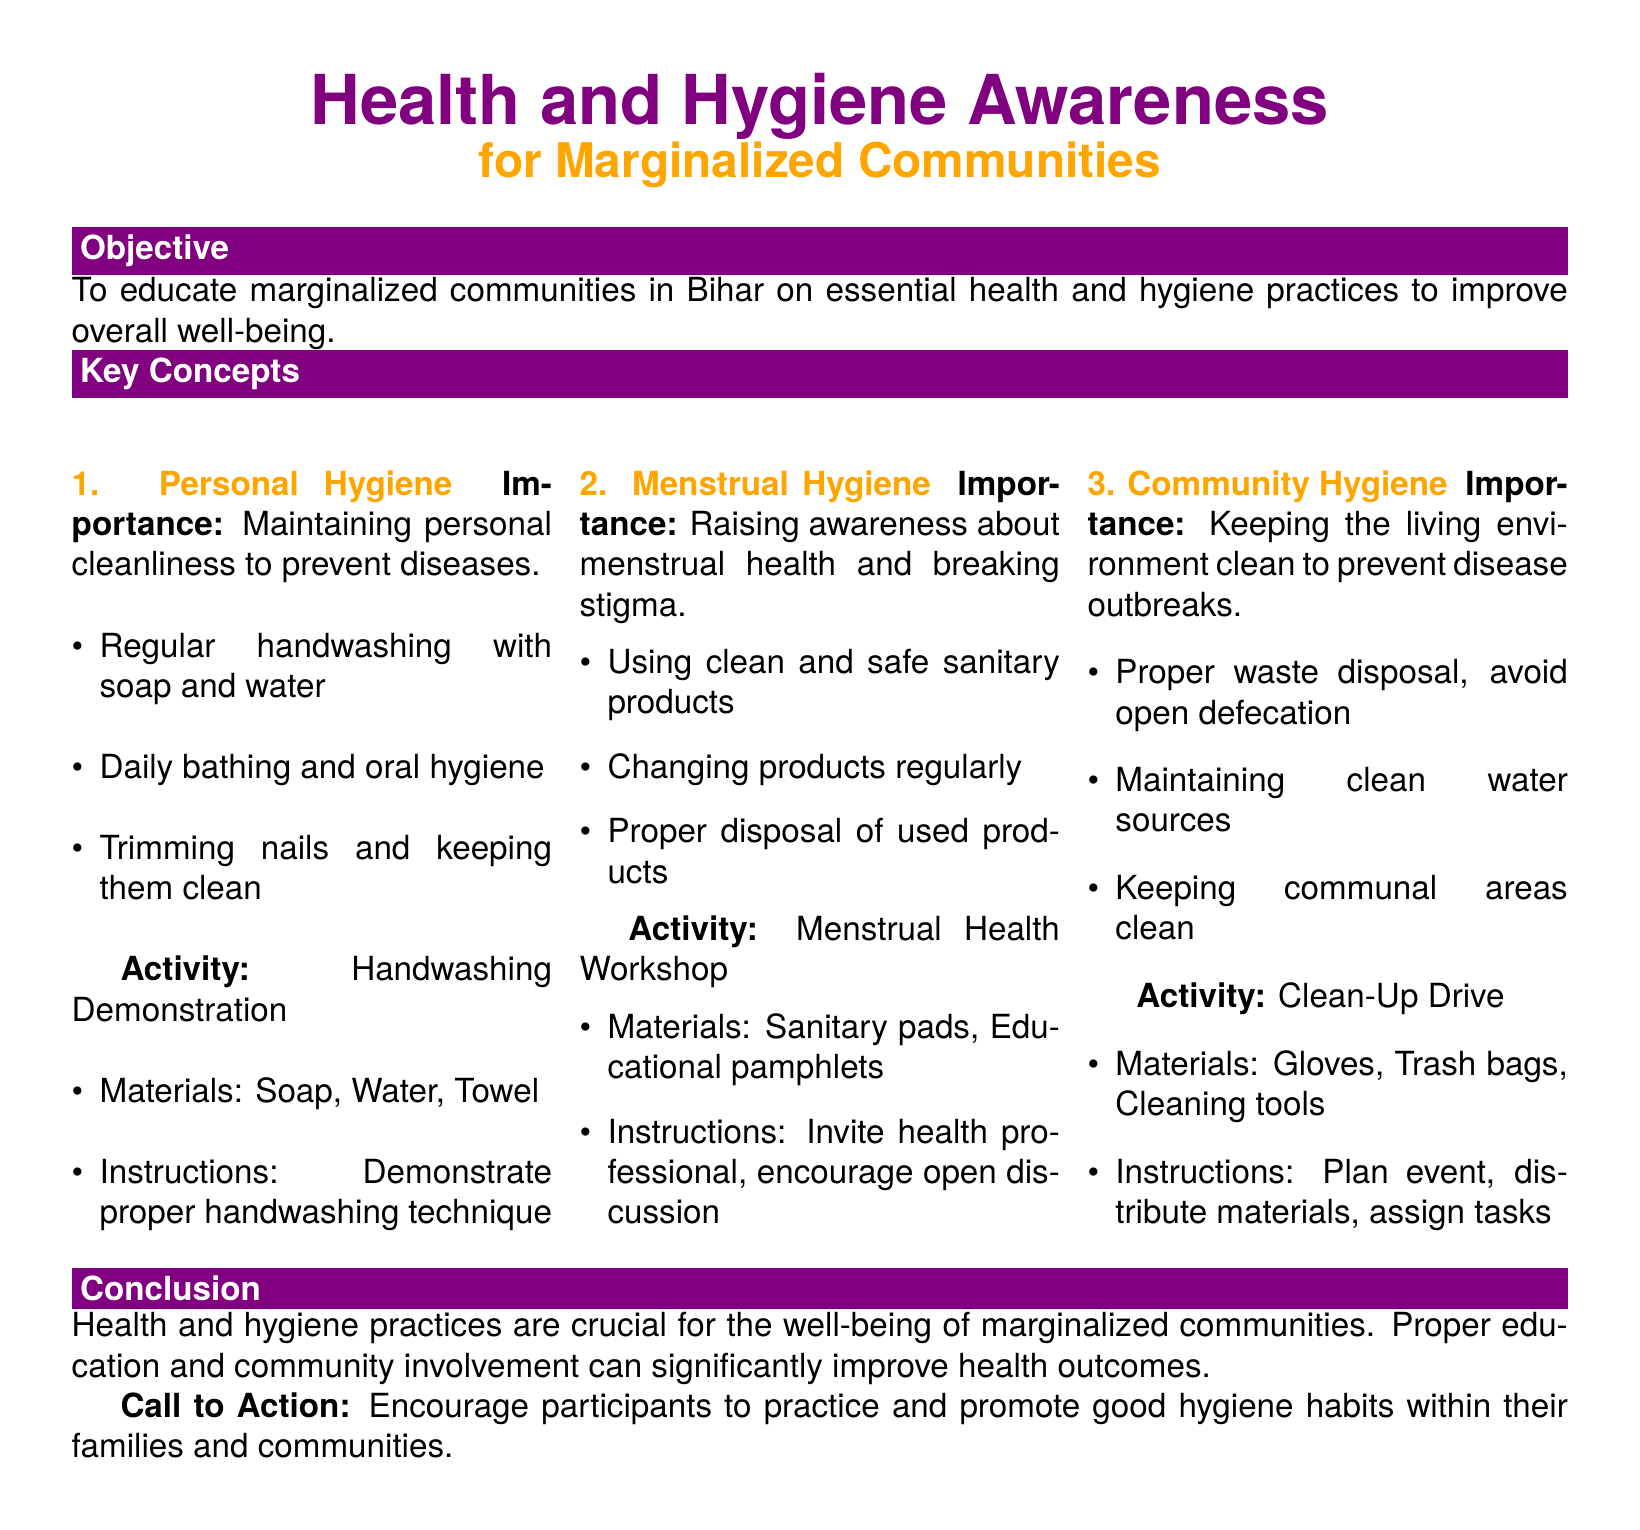What is the main objective of the lesson plan? The main objective is to educate marginalized communities in Bihar on essential health and hygiene practices to improve overall well-being.
Answer: To educate marginalized communities in Bihar on essential health and hygiene practices to improve overall well-being How many key concepts are discussed in the lesson plan? The document lists three key concepts related to health and hygiene awareness.
Answer: Three What is one activity related to personal hygiene? The activity listed for personal hygiene includes demonstrating proper handwashing technique as an educational exercise.
Answer: Handwashing Demonstration Which materials are needed for the menstrual health workshop? The materials required for the menstrual health workshop include sanitary pads and educational pamphlets.
Answer: Sanitary pads, Educational pamphlets What call to action is mentioned in the conclusion? The conclusion encourages participants to practice and promote good hygiene habits within their families and communities.
Answer: Encourage participants to practice and promote good hygiene habits within their families and communities What is the importance of community hygiene according to the document? The document emphasizes the importance of keeping the living environment clean to prevent disease outbreaks.
Answer: Keeping the living environment clean to prevent disease outbreaks What is one method mentioned for proper waste disposal? The document suggests avoiding open defecation as a method for proper waste disposal in maintaining community hygiene.
Answer: Avoid open defecation 